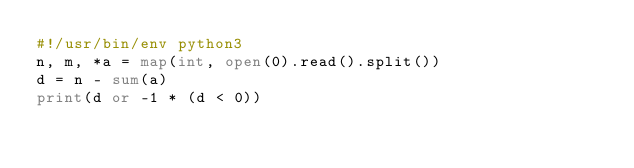<code> <loc_0><loc_0><loc_500><loc_500><_Python_>#!/usr/bin/env python3
n, m, *a = map(int, open(0).read().split())
d = n - sum(a)
print(d or -1 * (d < 0))
</code> 